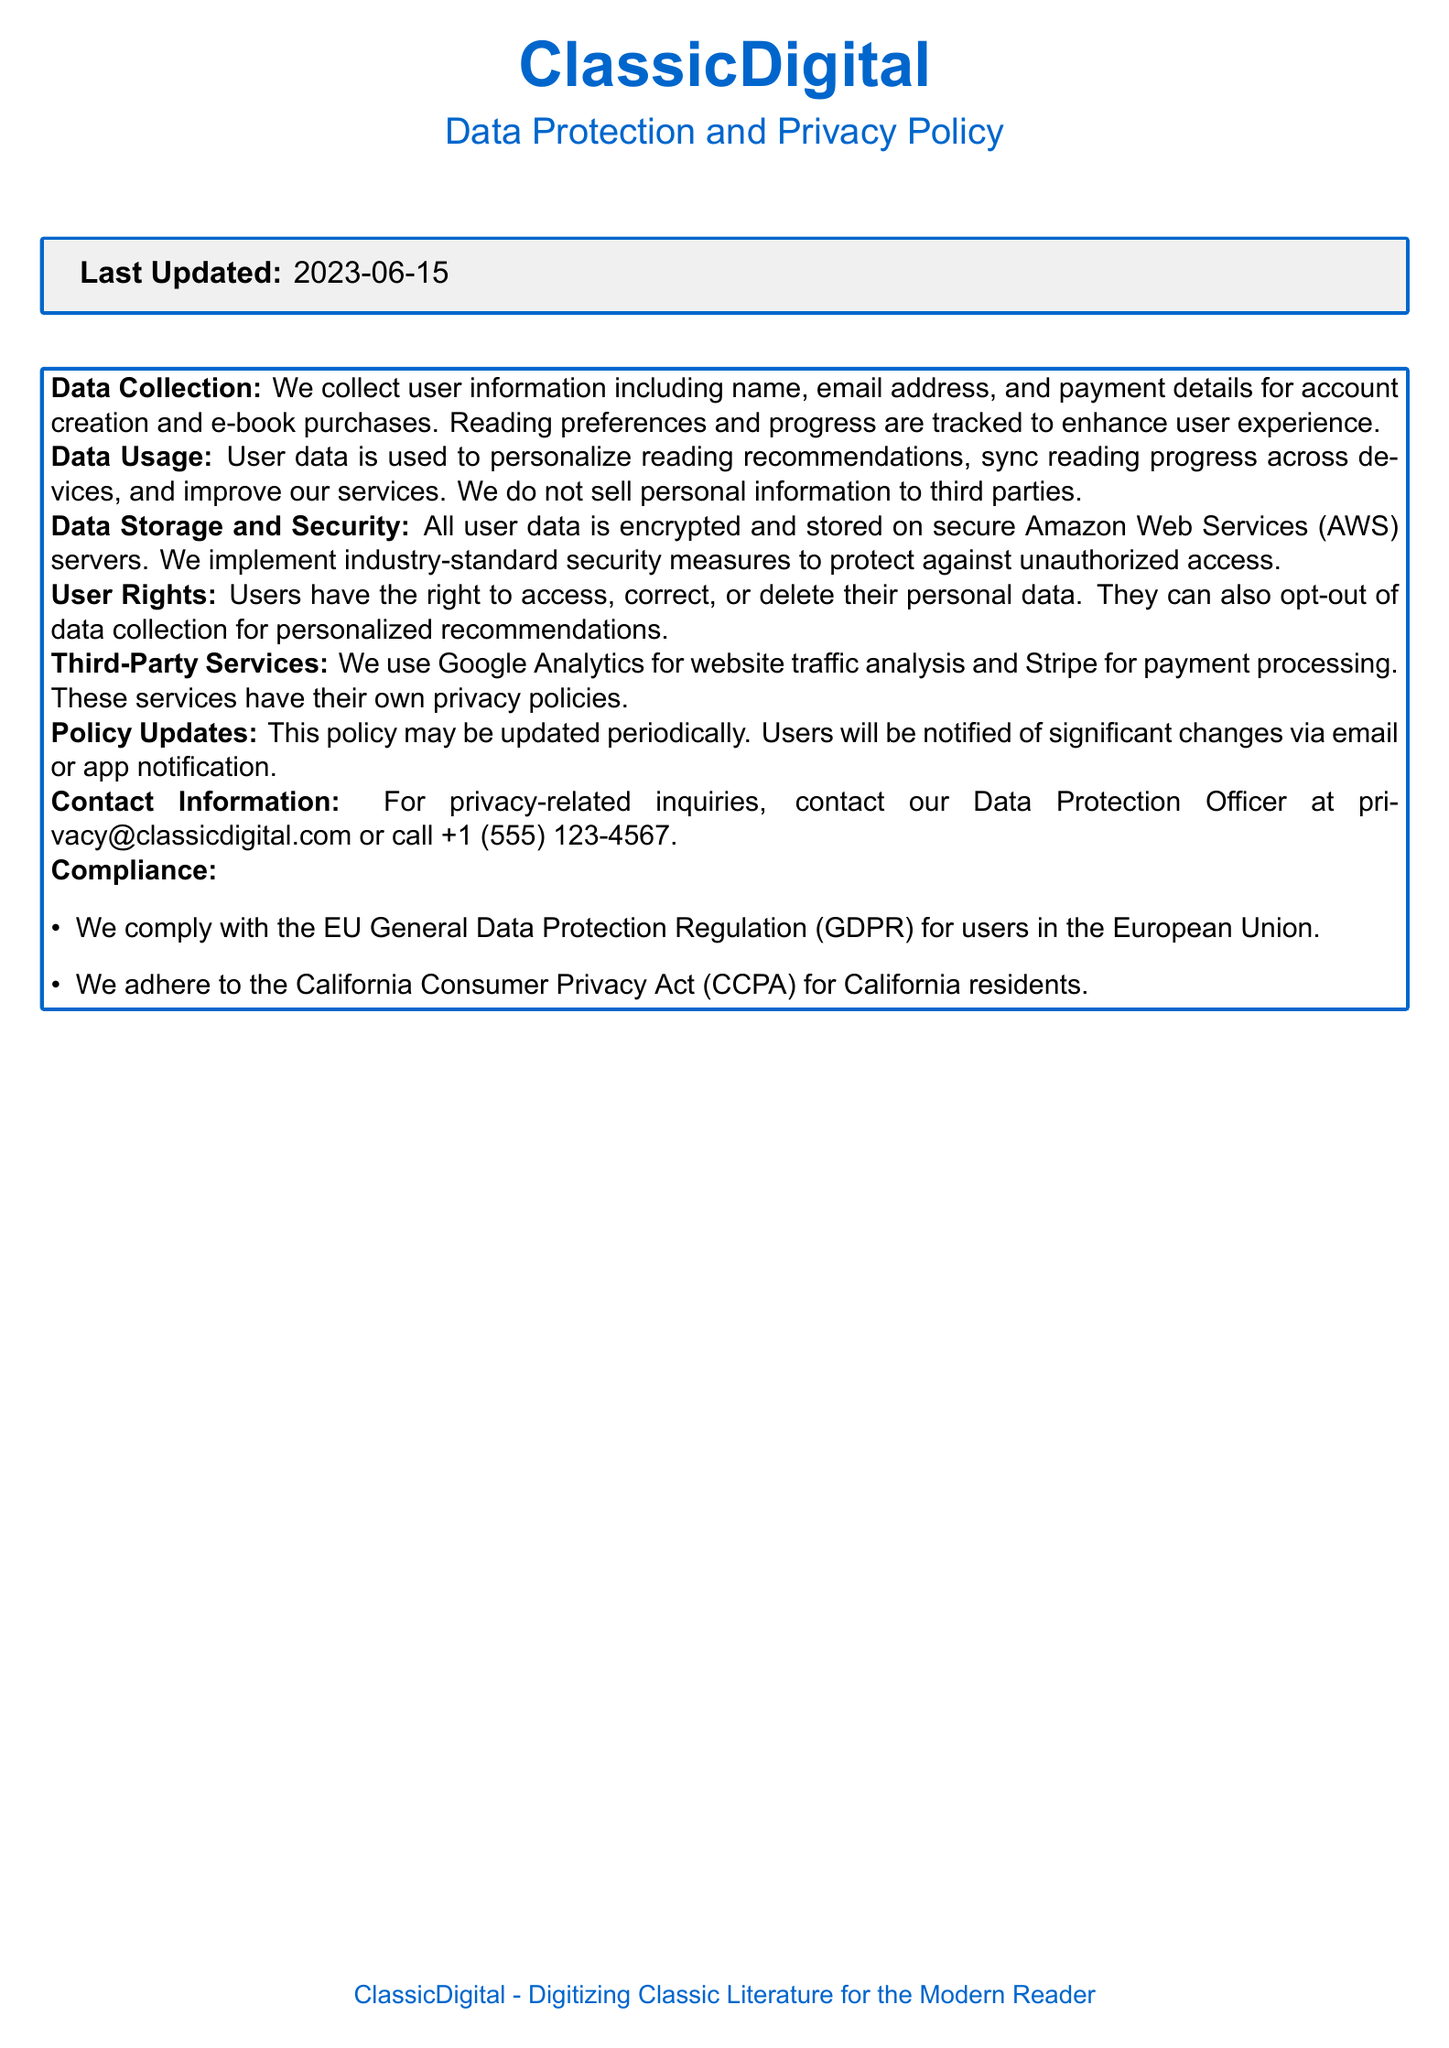What is the last updated date of the policy? The last updated date is stated in the document, which is a specific date related to the policy's revision.
Answer: 2023-06-15 What data do we collect from users? The document lists specific types of user information collected during account creation and e-book purchases.
Answer: Name, email address, and payment details Which services do we use for payment processing? The document specifies the third-party service used for processing payments, which is relevant for user transaction security.
Answer: Stripe What rights do users have regarding their personal data? The document outlines specific rights users have to manage their data, which is a crucial part of data protection.
Answer: Access, correct, or delete Which regulation do we comply with for the EU users? The document mentions compliance with specific regulations that protect user data in certain regions, highlighting legal adherence.
Answer: EU General Data Protection Regulation (GDPR) What is the purpose of collecting reading preferences? The document explains the reason for tracking reading preferences, which relates to user experience.
Answer: Enhance user experience How is user data stored? The document describes the storage solution used for securing user data, which is important for data privacy.
Answer: Encrypted and stored on secure Amazon Web Services (AWS) servers Who should users contact for privacy-related inquiries? The document provides specific contact information for privacy questions, guiding users on where to seek help.
Answer: privacy@classicdigital.com What does "opt-out of data collection" mean? The document describes a feature allowing users to refuse certain types of data collection, emphasizing user control over personal information.
Answer: Users can choose not to have their data collected for personalized recommendations 